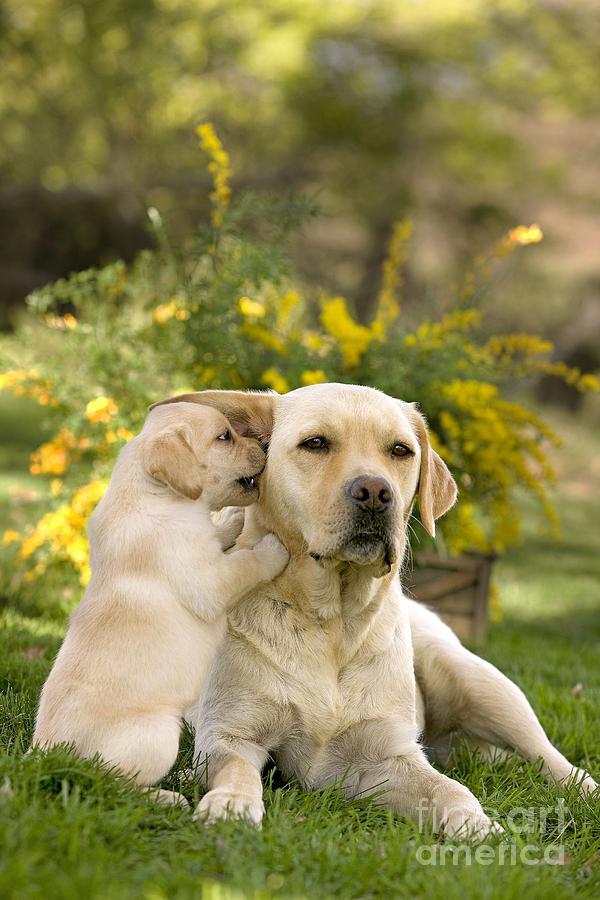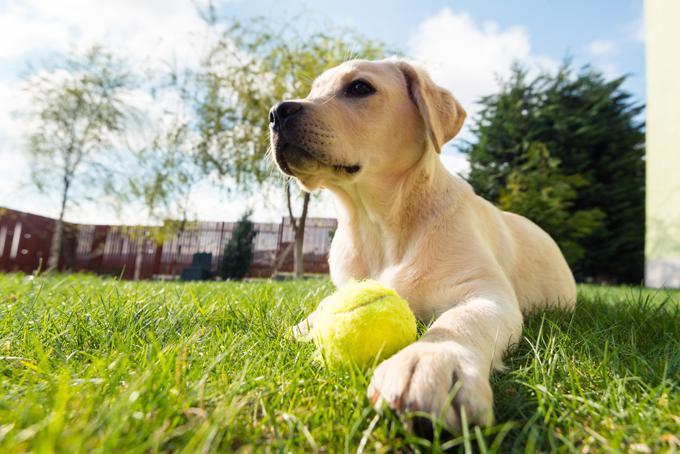The first image is the image on the left, the second image is the image on the right. For the images displayed, is the sentence "There are exactly two dogs in the left image." factually correct? Answer yes or no. Yes. 